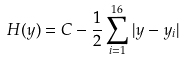<formula> <loc_0><loc_0><loc_500><loc_500>H ( y ) = C - \frac { 1 } { 2 } \sum _ { i = 1 } ^ { 1 6 } | y - y _ { i } |</formula> 